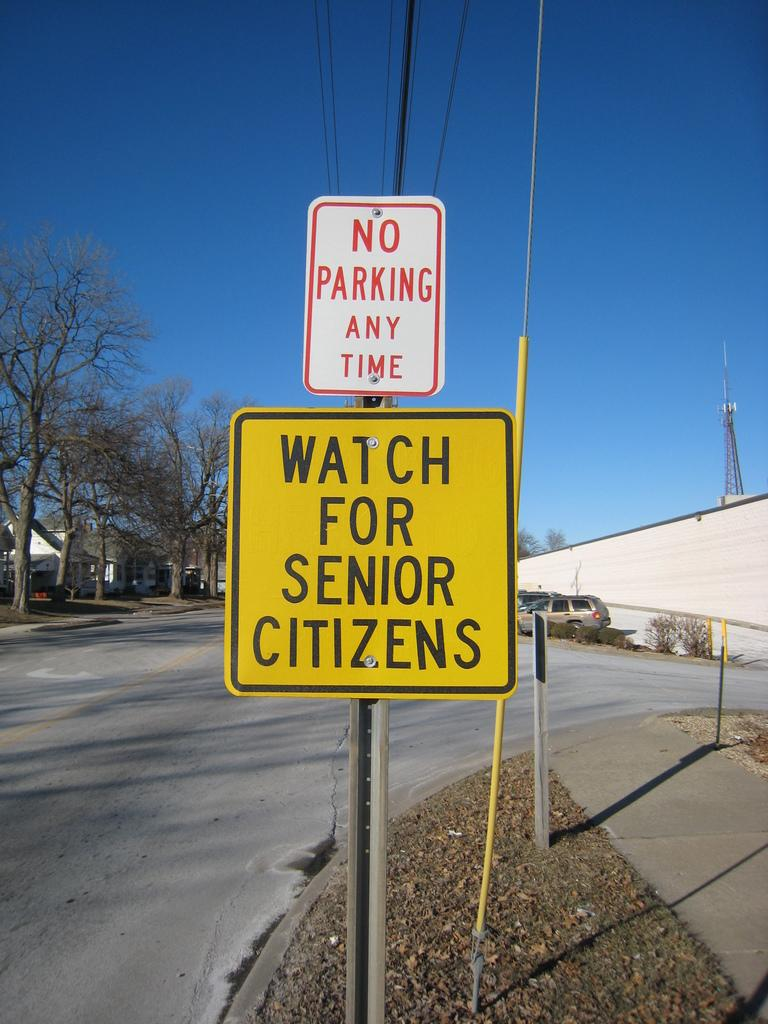<image>
Render a clear and concise summary of the photo. A residential street that has street signs that say No PARKING ANY TIME AND ON E SAYS wATCH FOR SENIOR CITIZENS. 